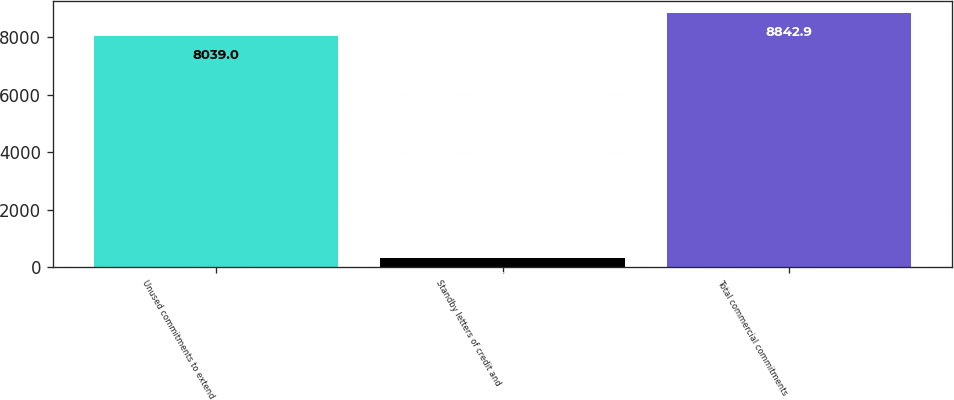Convert chart to OTSL. <chart><loc_0><loc_0><loc_500><loc_500><bar_chart><fcel>Unused commitments to extend<fcel>Standby letters of credit and<fcel>Total commercial commitments<nl><fcel>8039<fcel>314<fcel>8842.9<nl></chart> 